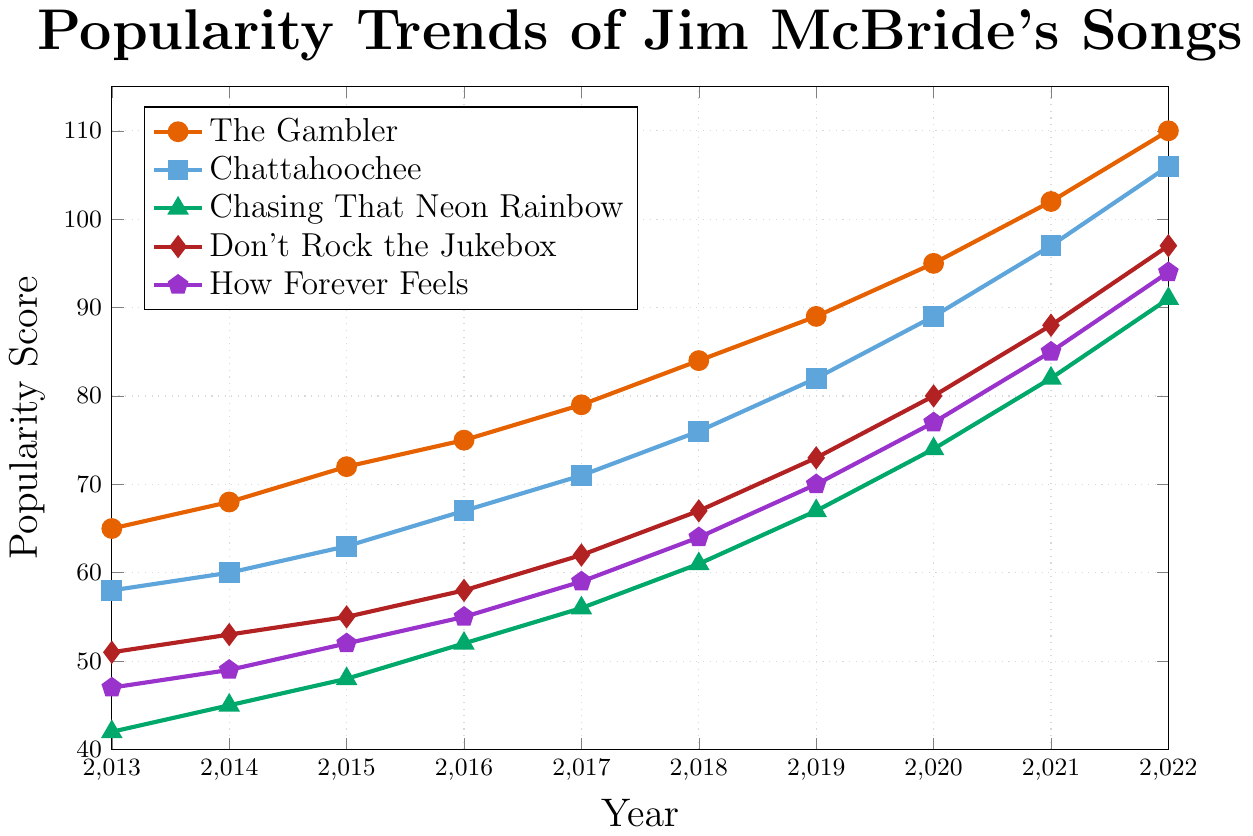What's the overall trend for the popularity of "The Gambler" from 2013 to 2022? The plot shows that the popularity score of "The Gambler" steadily increases every year from 65 in 2013 to 110 in 2022. This suggests a consistent upward trend in its popularity.
Answer: Steady increase Which song had the highest increase in popularity score between 2013 and 2022? By looking at the figure, we see the popularity scores in 2013 and 2022 for all songs: "The Gambler" (65 to 110), "Chattahoochee" (58 to 106), "Chasing That Neon Rainbow" (42 to 91), "Don't Rock the Jukebox" (51 to 97), and "How Forever Feels" (47 to 94). We calculate the increase for each song: "The Gambler" (45), "Chattahoochee" (48), "Chasing That Neon Rainbow" (49), "Don't Rock the Jukebox" (46), and "How Forever Feels" (47). The highest increase is for "Chasing That Neon Rainbow" with a 49-point increase.
Answer: Chasing That Neon Rainbow In what year did "Chattahoochee" surpass a popularity score of 90? Referring to the figure, "Chattahoochee" reaches a popularity score of 97 in 2021, which is the first year its score exceeds 90.
Answer: 2021 What is the sum of the popularity scores for "How Forever Feels" in 2018 and "Don't Rock the Jukebox" in 2018? From the figure, the popularity score for "How Forever Feels" in 2018 is 64, and for "Don't Rock the Jukebox" in 2018, it is 67. Summing these values, 64 + 67 = 131.
Answer: 131 Which song had a higher popularity score in 2016, "Chasing That Neon Rainbow" or "How Forever Feels"? Looking at the figure, I see in 2016 "Chasing That Neon Rainbow" has a popularity score of 52, while "How Forever Feels" has a score of 55. Comparatively, "How Forever Feels" has a higher popularity score in 2016.
Answer: How Forever Feels What is the average popularity score of "Don't Rock the Jukebox" from 2013 to 2022? For "Don't Rock the Jukebox", we collect the popularity scores: 51, 53, 55, 58, 62, 67, 73, 80, 88, 97. By adding these values: 51 + 53 + 55 + 58 + 62 + 67 + 73 + 80 + 88 + 97 = 684. The average is calculated by dividing the sum by the number of years (10): 684 / 10 = 68.4.
Answer: 68.4 Which year saw the biggest year-on-year increase in the popularity of "Chattahoochee"? Looking at the plot, subtract the score for "Chattahoochee" for each year from the score of the previous year: 2014 (60 - 58 = 2), 2015 (63 - 60 = 3), 2016 (67 - 63 = 4), 2017 (71 - 67 = 4), 2018 (76 - 71 = 5), 2019 (82 - 76 = 6), 2020 (89 - 82 = 7), 2021 (97 - 89 = 8), and 2022 (106 - 97 = 9). The biggest increase is from 2021 to 2022, with 9 points.
Answer: 2022 By what percentage did the popularity of "The Gambler" increase from 2013 to 2020? The popularity of "The Gambler" in 2013 is 65, and in 2020 it is 95. The increase is 95 - 65 = 30. The percentage increase is calculated as (30 / 65) * 100 = 46.15%.
Answer: 46.15% Are there any songs that reached a popularity score of 100 or higher by 2022? If so, which ones? From the plot, by 2022, "The Gambler" (110), "Chattahoochee" (106), and "Don't Rock the Jukebox" (97) all exceed or equal a popularity score of 100.
Answer: The Gambler, Chattahoochee How many songs had a popularity score below 50 in 2013? From the plot, we observe the popularity scores in 2013: "The Gambler" (65), "Chattahoochee" (58), "Chasing That Neon Rainbow" (42), "Don't Rock the Jukebox" (51), and "How Forever Feels" (47). Two songs, "Chasing That Neon Rainbow" and "How Forever Feels", have scores below 50.
Answer: 2 